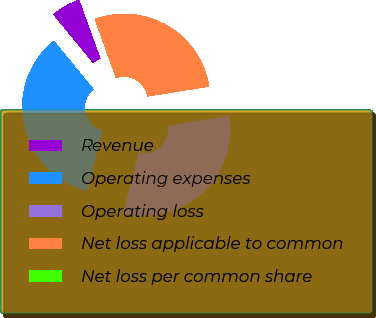Convert chart. <chart><loc_0><loc_0><loc_500><loc_500><pie_chart><fcel>Revenue<fcel>Operating expenses<fcel>Operating loss<fcel>Net loss applicable to common<fcel>Net loss per common share<nl><fcel>5.41%<fcel>35.13%<fcel>31.49%<fcel>27.97%<fcel>0.0%<nl></chart> 